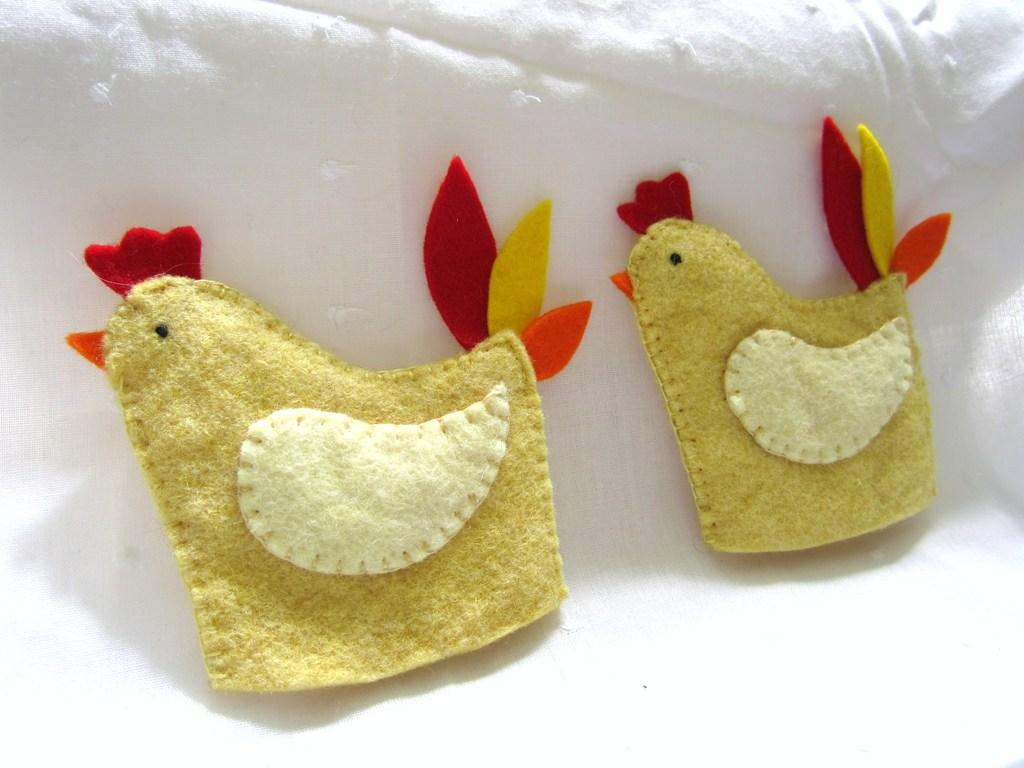What type of items are visible in the image? There are embroidery patches in the image. What is the color of the cloth on which the embroidery patches are placed? The embroidery patches are on a white-colored cloth. How many sheep are visible in the image? There are no sheep present in the image; it features embroidery patches on a white-colored cloth. Where is the nest located in the image? There is no nest present in the image; it features embroidery patches on a white-colored cloth. 